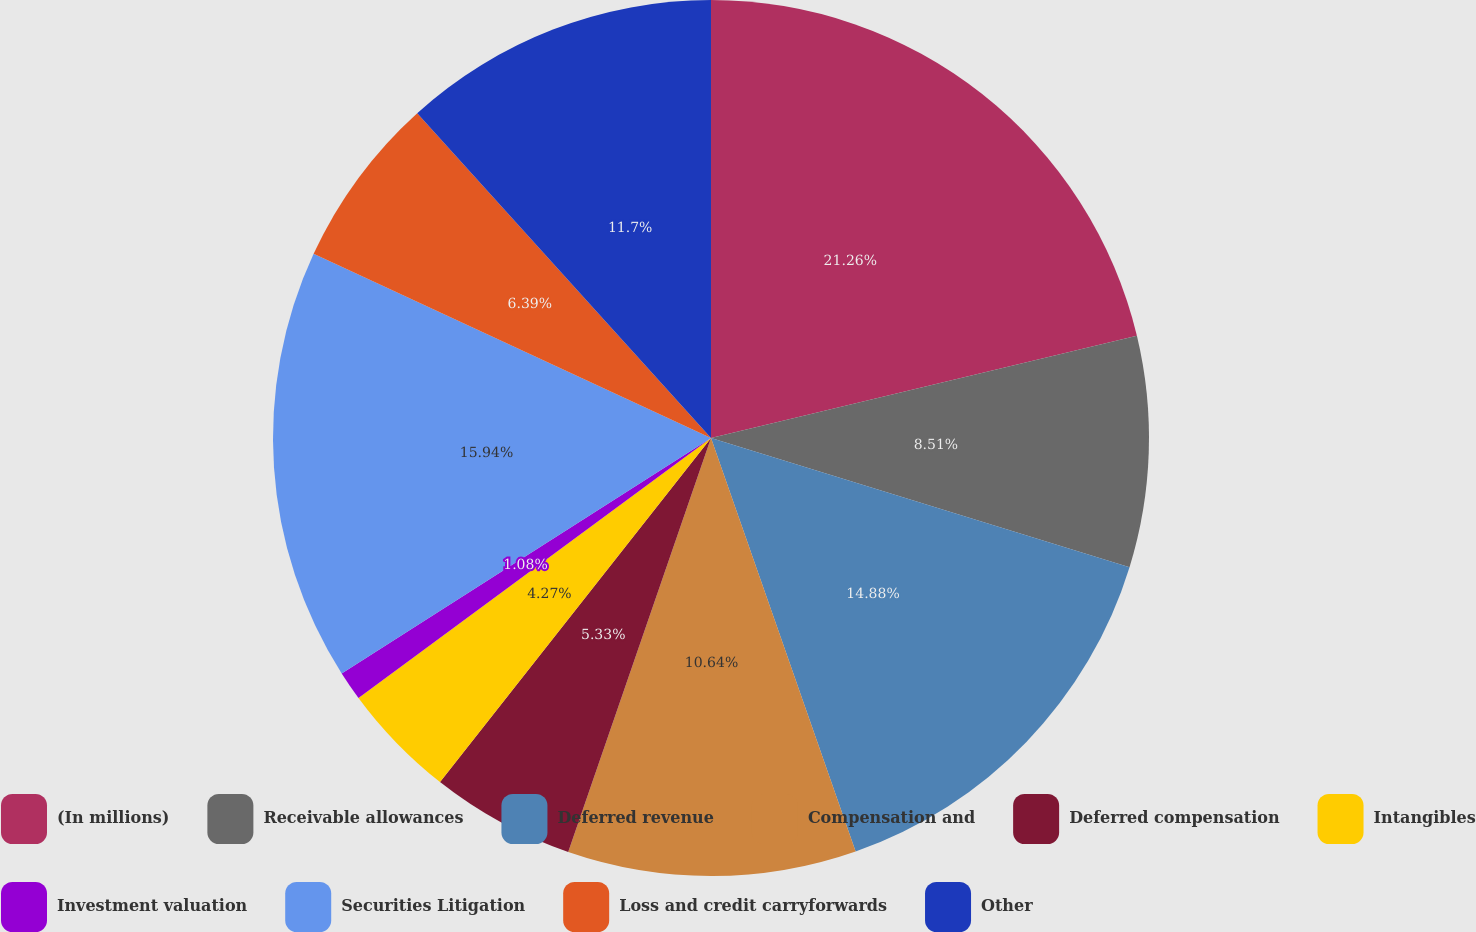<chart> <loc_0><loc_0><loc_500><loc_500><pie_chart><fcel>(In millions)<fcel>Receivable allowances<fcel>Deferred revenue<fcel>Compensation and<fcel>Deferred compensation<fcel>Intangibles<fcel>Investment valuation<fcel>Securities Litigation<fcel>Loss and credit carryforwards<fcel>Other<nl><fcel>21.25%<fcel>8.51%<fcel>14.88%<fcel>10.64%<fcel>5.33%<fcel>4.27%<fcel>1.08%<fcel>15.94%<fcel>6.39%<fcel>11.7%<nl></chart> 